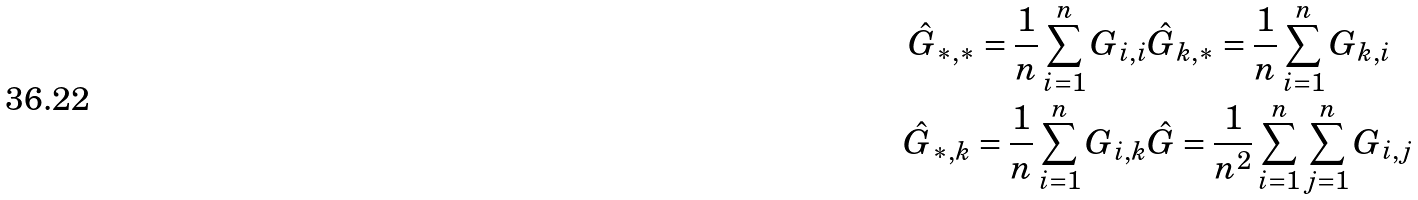<formula> <loc_0><loc_0><loc_500><loc_500>\hat { G } _ { * , * } = \frac { 1 } { n } \sum _ { i = 1 } ^ { n } G _ { i , i } & \hat { G } _ { k , * } = \frac { 1 } { n } \sum _ { i = 1 } ^ { n } G _ { k , i } \\ \hat { G } _ { * , k } = \frac { 1 } { n } \sum _ { i = 1 } ^ { n } G _ { i , k } & \hat { G } = \frac { 1 } { n ^ { 2 } } \sum _ { i = 1 } ^ { n } \sum _ { j = 1 } ^ { n } G _ { i , j }</formula> 